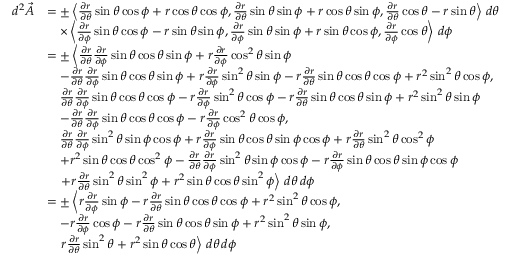Convert formula to latex. <formula><loc_0><loc_0><loc_500><loc_500>\begin{array} { r l } { d ^ { 2 } \vec { A } } & { = \pm \left \langle \frac { \partial r } { \partial \theta } \sin \theta \cos \phi + r \cos \theta \cos \phi , \frac { \partial r } { \partial \theta } \sin \theta \sin \phi + r \cos \theta \sin \phi , \frac { \partial r } { \partial \theta } \cos \theta - r \sin \theta \right \rangle \, d \theta } \\ & { \quad \times \left \langle \frac { \partial r } { \partial \phi } \sin \theta \cos \phi - r \sin \theta \sin \phi , \frac { \partial r } { \partial \phi } \sin \theta \sin \phi + r \sin \theta \cos \phi , \frac { \partial r } { \partial \phi } \cos \theta \right \rangle \, d \phi } \\ & { = \pm \left \langle \frac { \partial r } { \partial \theta } \frac { \partial r } { \partial \phi } \sin \theta \cos \theta \sin \phi + r \frac { \partial r } { \partial \phi } \cos ^ { 2 } \theta \sin \phi } \\ & { \quad - \frac { \partial r } { \partial \theta } \frac { \partial r } { \partial \phi } \sin \theta \cos \theta \sin \phi + r \frac { \partial r } { \partial \phi } \sin ^ { 2 } \theta \sin \phi - r \frac { \partial r } { \partial \theta } \sin \theta \cos \theta \cos \phi + r ^ { 2 } \sin ^ { 2 } \theta \cos \phi , } \\ & { \quad \frac { \partial r } { \partial \theta } \frac { \partial r } { \partial \phi } \sin \theta \cos \theta \cos \phi - r \frac { \partial r } { \partial \phi } \sin ^ { 2 } \theta \cos \phi - r \frac { \partial r } { \partial \theta } \sin \theta \cos \theta \sin \phi + r ^ { 2 } \sin ^ { 2 } \theta \sin \phi } \\ & { \quad - \frac { \partial r } { \partial \theta } \frac { \partial r } { \partial \phi } \sin \theta \cos \theta \cos \phi - r \frac { \partial r } { \partial \phi } \cos ^ { 2 } \theta \cos \phi , } \\ & { \quad \frac { \partial r } { \partial \theta } \frac { \partial r } { \partial \phi } \sin ^ { 2 } \theta \sin \phi \cos \phi + r \frac { \partial r } { \partial \phi } \sin \theta \cos \theta \sin \phi \cos \phi + r \frac { \partial r } { \partial \theta } \sin ^ { 2 } \theta \cos ^ { 2 } \phi } \\ & { \quad + r ^ { 2 } \sin \theta \cos \theta \cos ^ { 2 } \phi - \frac { \partial r } { \partial \theta } \frac { \partial r } { \partial \phi } \sin ^ { 2 } \theta \sin \phi \cos \phi - r \frac { \partial r } { \partial \phi } \sin \theta \cos \theta \sin \phi \cos \phi } \\ & { \quad + r \frac { \partial r } { \partial \theta } \sin ^ { 2 } \theta \sin ^ { 2 } \phi + r ^ { 2 } \sin \theta \cos \theta \sin ^ { 2 } \phi \right \rangle \, d \theta \, d \phi } \\ & { = \pm \left \langle r \frac { \partial r } { \partial \phi } \sin \phi - r \frac { \partial r } { \partial \theta } \sin \theta \cos \theta \cos \phi + r ^ { 2 } \sin ^ { 2 } \theta \cos \phi , } \\ & { \quad - r \frac { \partial r } { \partial \phi } \cos \phi - r \frac { \partial r } { \partial \theta } \sin \theta \cos \theta \sin \phi + r ^ { 2 } \sin ^ { 2 } \theta \sin \phi , } \\ & { \quad r \frac { \partial r } { \partial \theta } \sin ^ { 2 } \theta + r ^ { 2 } \sin \theta \cos \theta \right \rangle \, d \theta \, d \phi } \end{array}</formula> 